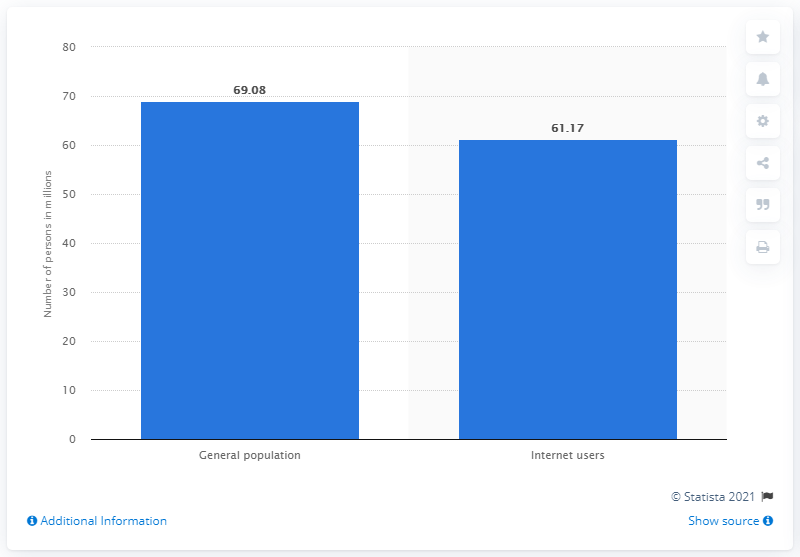List a handful of essential elements in this visual. In November 2020, there were 61.17 million people using the internet in Germany. 